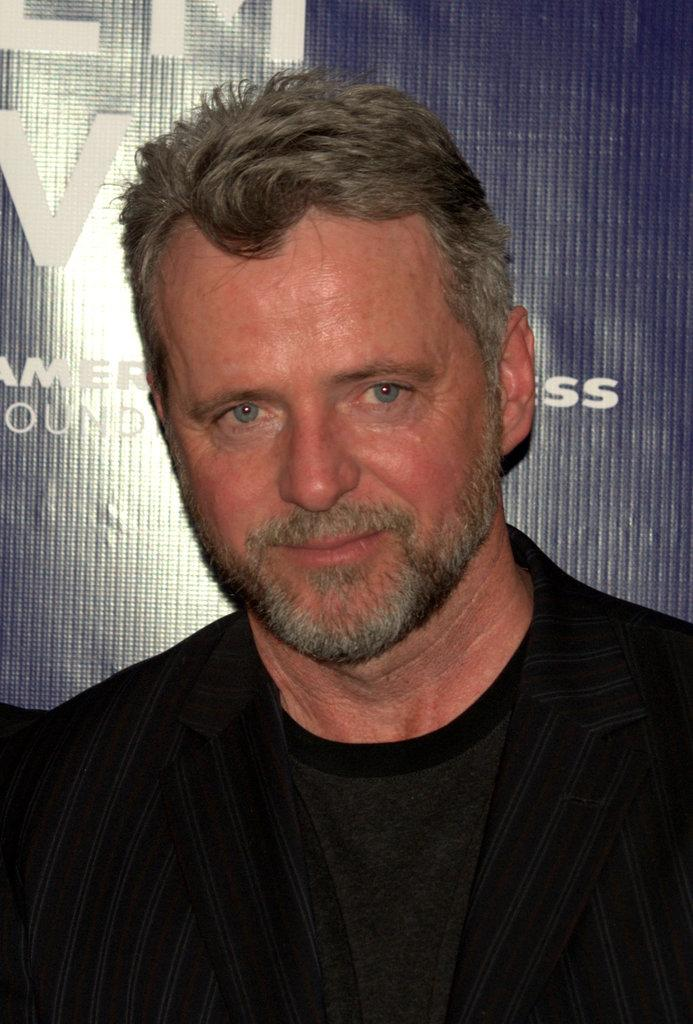Who or what is the main subject in the image? There is a person in the image. What is located behind the person in the image? There is a banner with text behind the person. What type of creature can be seen interacting with the banner in the image? There is no creature present in the image; it only features a person and a banner with text. What iron-related detail can be observed in the image? There is no iron-related detail present in the image. 